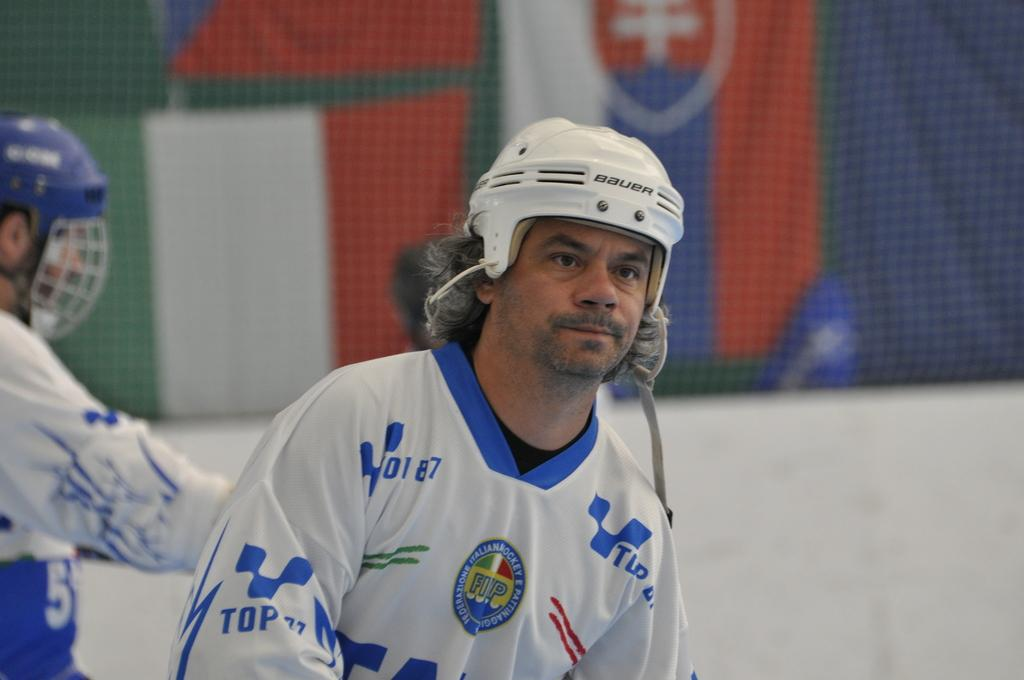How many people are in the image? There are two persons in the image. What are the persons wearing on their heads? The persons are wearing helmets. Can you describe the background of the image? The background of the image is blurry. What type of object can be seen in the background? There is a cloth-like object in the background of the image. What type of credit can be seen being offered in the image? There is no credit being offered in the image; it features two persons wearing helmets with a blurry background and a cloth-like object. What type of treatment is being administered to the persons in the image? There is no treatment being administered to the persons in the image; they are simply wearing helmets. 